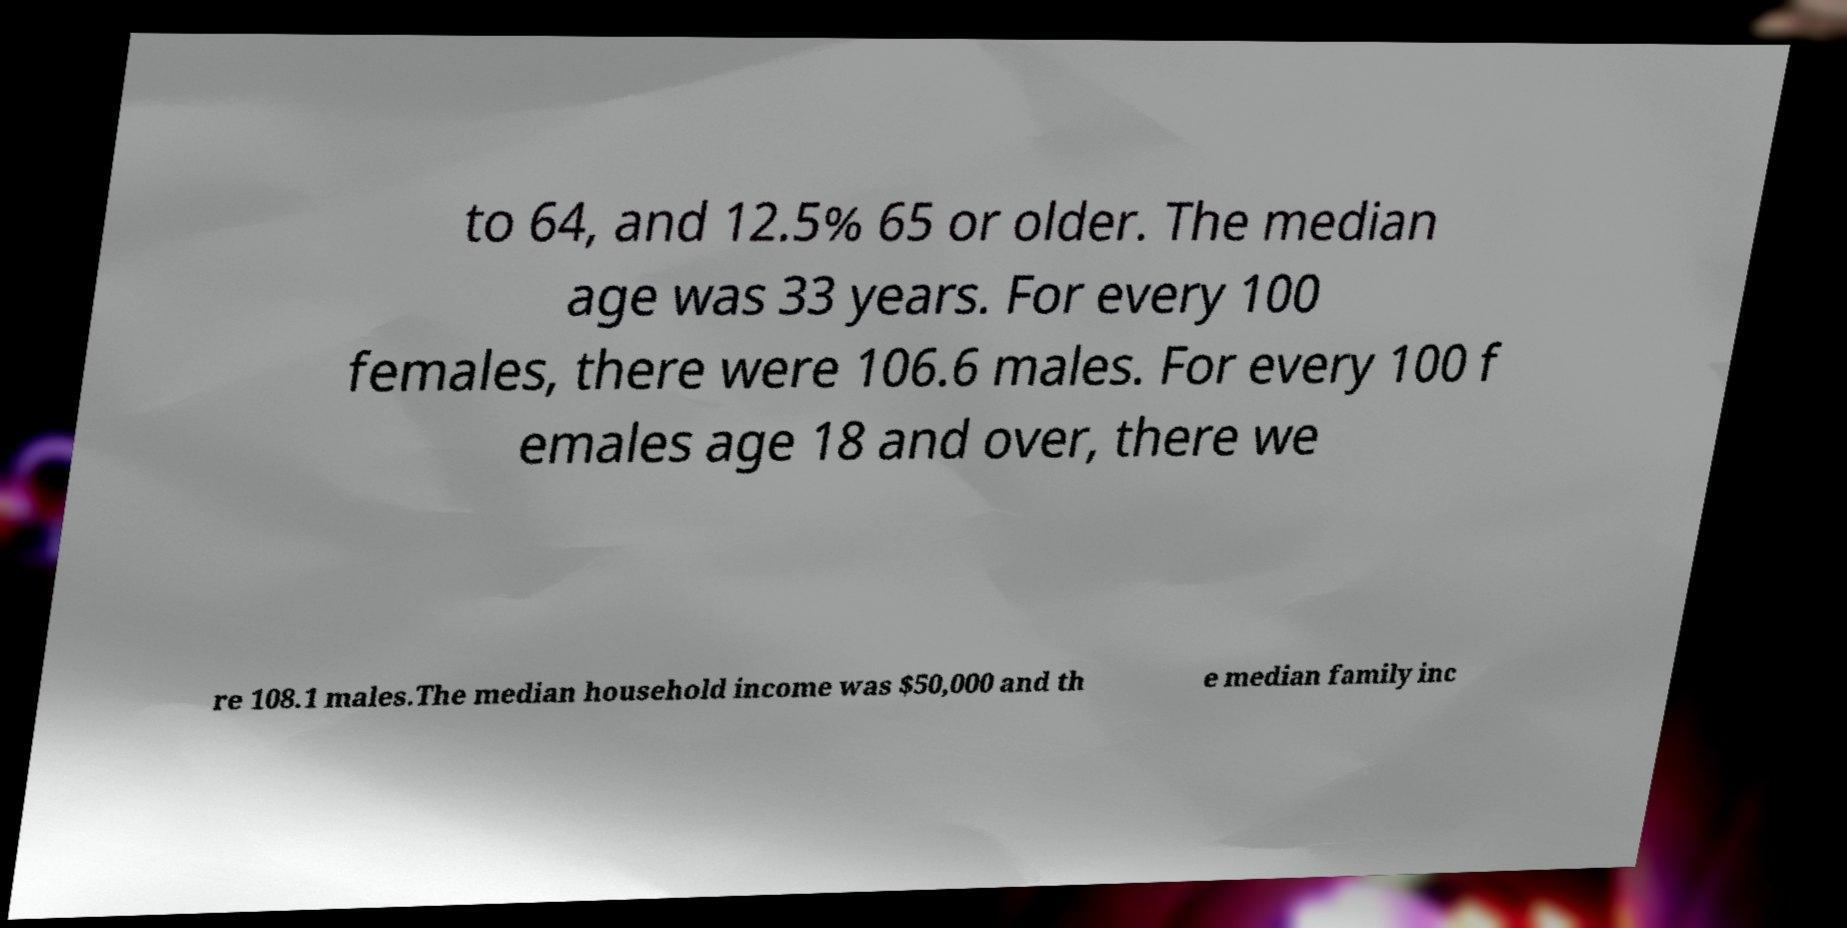For documentation purposes, I need the text within this image transcribed. Could you provide that? to 64, and 12.5% 65 or older. The median age was 33 years. For every 100 females, there were 106.6 males. For every 100 f emales age 18 and over, there we re 108.1 males.The median household income was $50,000 and th e median family inc 